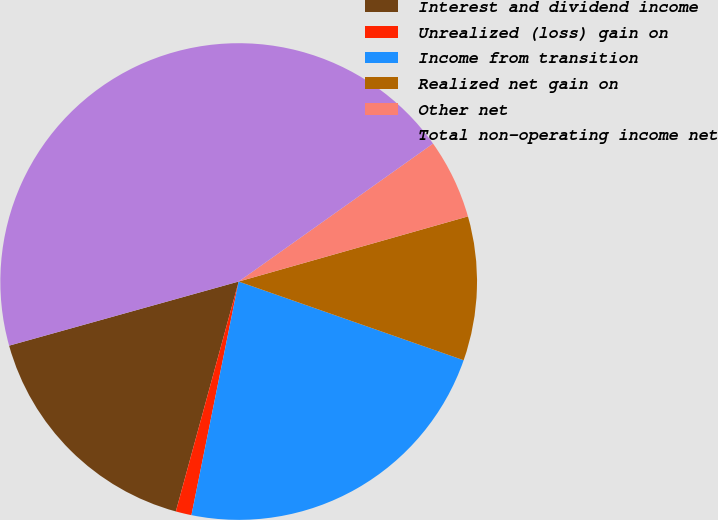Convert chart to OTSL. <chart><loc_0><loc_0><loc_500><loc_500><pie_chart><fcel>Interest and dividend income<fcel>Unrealized (loss) gain on<fcel>Income from transition<fcel>Realized net gain on<fcel>Other net<fcel>Total non-operating income net<nl><fcel>16.42%<fcel>1.07%<fcel>22.82%<fcel>9.76%<fcel>5.42%<fcel>44.51%<nl></chart> 